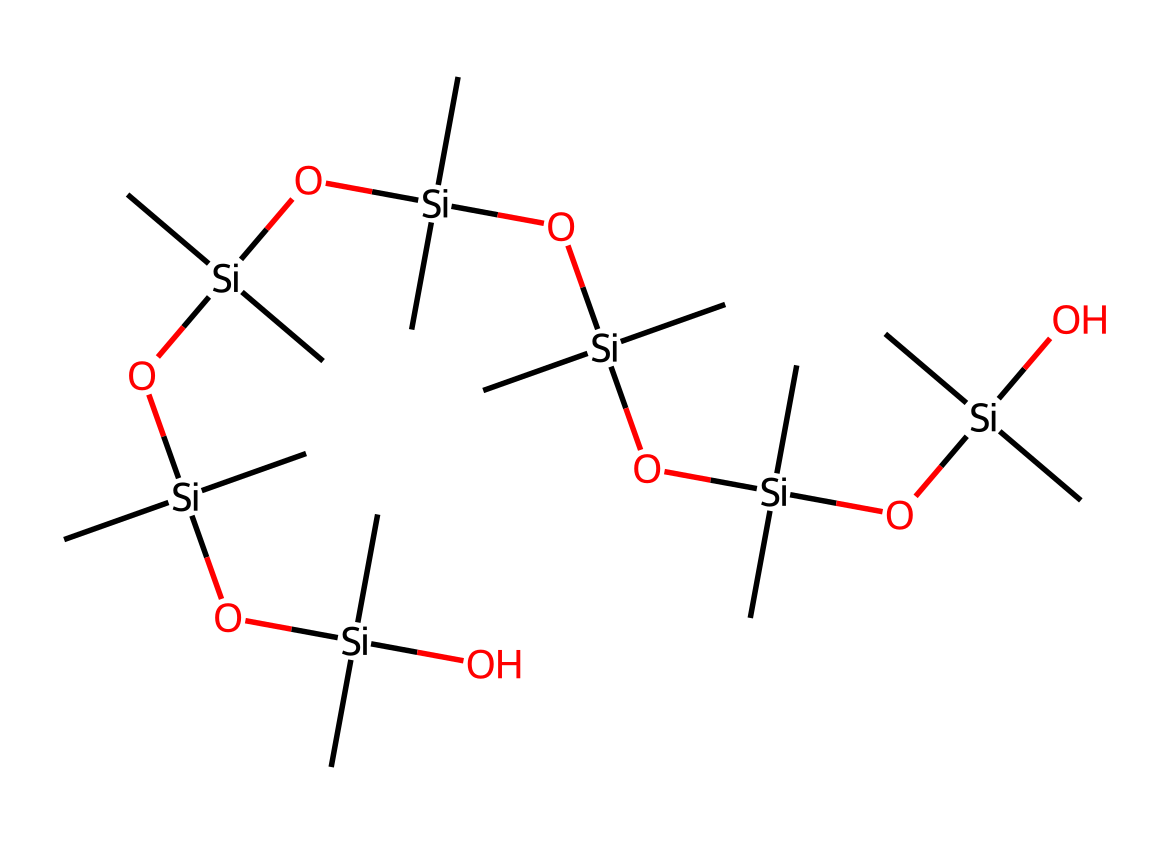how many silicon atoms are in the structure? By examining the SMILES representation, we count the 'Si' symbols, which represent silicon atoms. In this structure, there are 7 occurrences of 'Si'.
Answer: 7 how many oxygen atoms are in the structure? Counting the number of 'O' symbols in the SMILES representation gives us the count of oxygen atoms. In this representation, there are 6 occurrences of 'O'.
Answer: 6 what type of chemical is represented by this structure? The presence of silicon and oxygen in the structure indicates that it is an organosilicon compound, which commonly includes multiple siloxane linkages.
Answer: organosilicon compound what characteristic does this compound impart to silicone sealants? The structure's siloxane bonds (Si-O) provide flexibility and water resistance, which are essential for effective sealants in construction materials.
Answer: flexibility how does the branching affect the properties of this silicone compound? The branching in the structure contributes to lower viscosity and enhances the ability of the sealant to form a cohesive bond, making it easier to apply.
Answer: lower viscosity what is the significance of the methyl groups in the structure? The methyl groups (-C) enhance the hydrophobic properties of the compound, making it resistant to moisture, which is vital for outdoor applications in Norwegian homes.
Answer: hydrophobic properties what role do the silanol groups play in the sealant behavior? Silanol groups (-Si-OH) contribute to adhesion by forming hydrogen bonds with surfaces, improving the sealant's ability to stick to various materials.
Answer: adhesion 